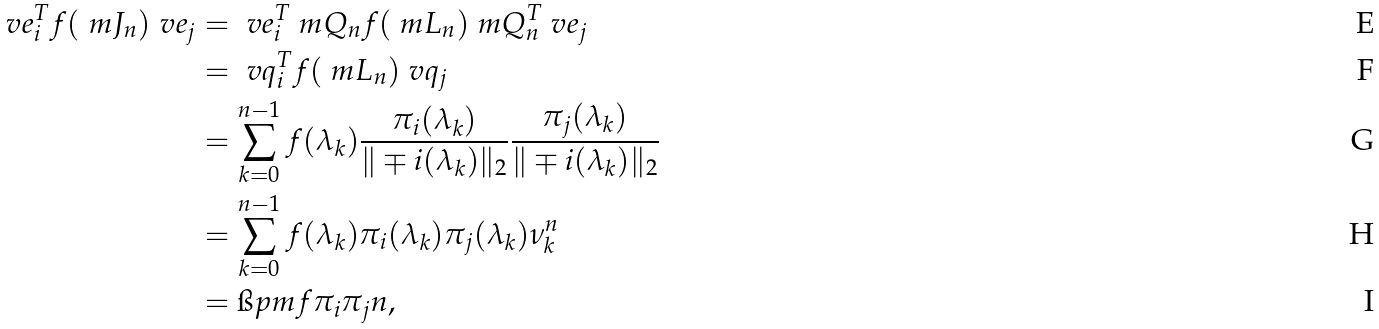<formula> <loc_0><loc_0><loc_500><loc_500>\ v e _ { i } ^ { T } f ( \ m J _ { n } ) \ v e _ { j } & = \ v e _ { i } ^ { T } \ m Q _ { n } f ( \ m L _ { n } ) \ m Q _ { n } ^ { T } \ v e _ { j } \\ & = \ v q _ { i } ^ { T } f ( \ m L _ { n } ) \ v q _ { j } \\ & = \sum _ { k = 0 } ^ { n - 1 } f ( \lambda _ { k } ) \frac { \pi _ { i } ( \lambda _ { k } ) } { \| \mp i ( \lambda _ { k } ) \| _ { 2 } } \frac { \pi _ { j } ( \lambda _ { k } ) } { \| \mp i ( \lambda _ { k } ) \| _ { 2 } } \\ & = \sum _ { k = 0 } ^ { n - 1 } f ( \lambda _ { k } ) \pi _ { i } ( \lambda _ { k } ) \pi _ { j } ( \lambda _ { k } ) \nu _ { k } ^ { n } \\ & = \i p m { f \pi _ { i } \pi _ { j } } { n } ,</formula> 